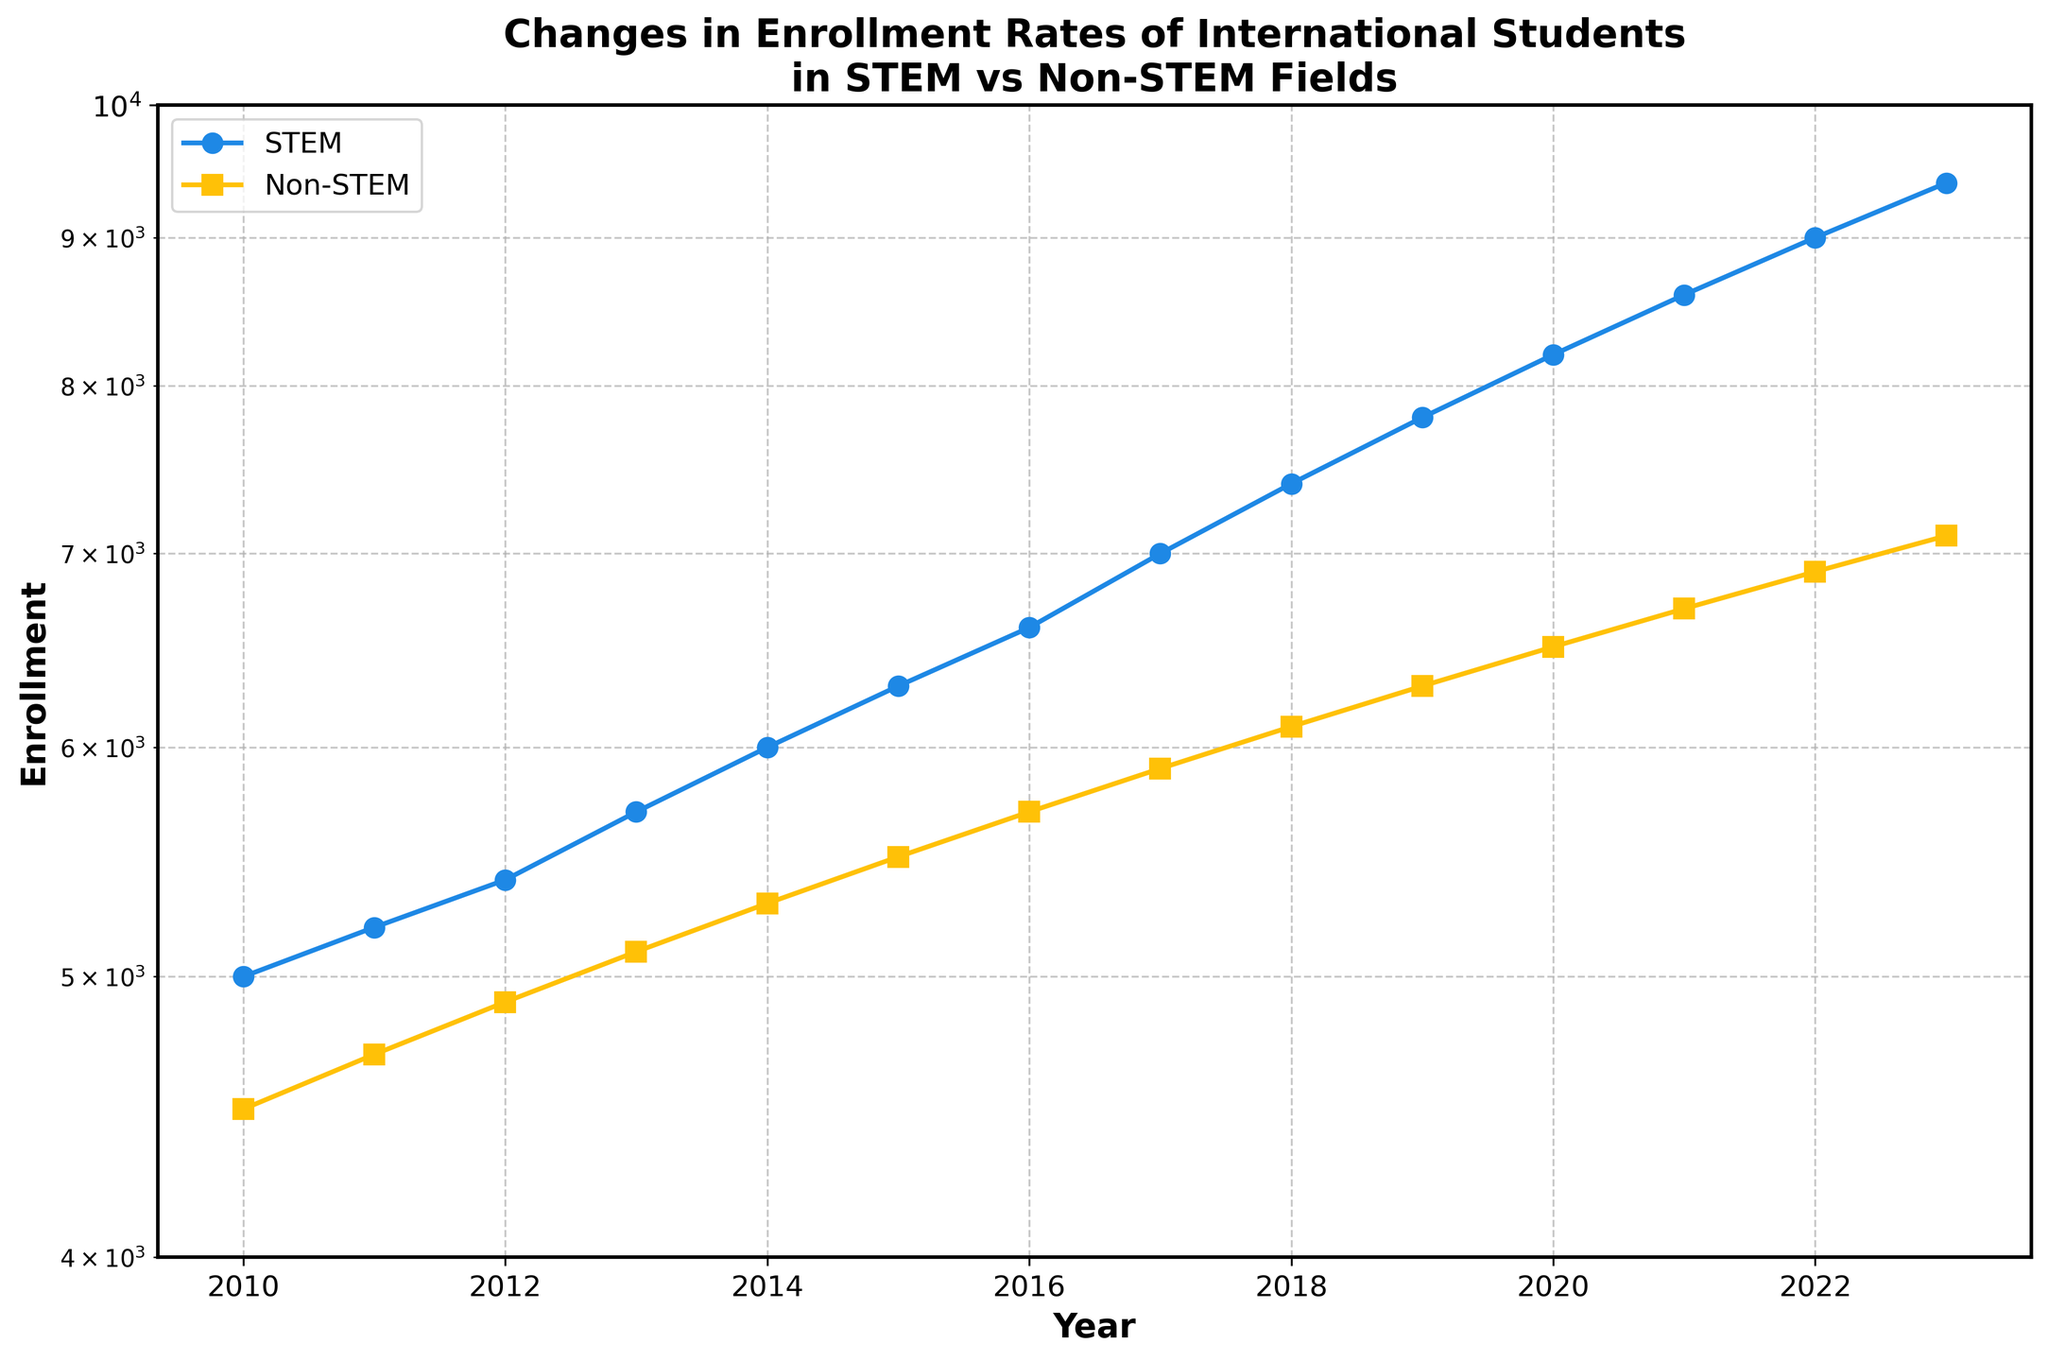What is the title of the plot? The title of the plot is displayed at the top and reads, "Changes in Enrollment Rates of International Students in STEM vs Non-STEM Fields".
Answer: Changes in Enrollment Rates of International Students in STEM vs Non-STEM Fields How many years of data are presented in the plot? The x-axis of the plot shows years ranging from 2010 to 2023, inclusive. To find the number of data points, count each year in this range.
Answer: 14 Which field, STEM or Non-STEM, had higher enrollment in 2013? Look at the values for 2013 on the plot. Compare the enrollment rates for STEM and Non-STEM fields. STEM enrollment is higher.
Answer: STEM What enrollment trend do both STEM and Non-STEM fields show from 2010 to 2023? Observe the direction of both lines on the plot from 2010 to 2023. Both lines show an increasing trend, indicating that enrollment in both fields has increased over these years.
Answer: Increasing In which year does the enrollment for STEM first surpass 7000? Trace the STEM line to find the year where the enrollment first exceeds the 7000 mark by following the y-axis labels. This occurs around 2017.
Answer: 2017 What is the enrollment difference between STEM and Non-STEM fields in 2023? Find the enrollment values for both fields in 2023 from the plot. Subtract the Non-STEM enrollment (7100) from STEM enrollment (9400).
Answer: 2300 How does the enrollment growth rate compare between STEM and Non-STEM fields? Compare the slopes of the two lines. The STEM enrollment line rises more steeply compared to the Non-STEM enrollment line, indicating a higher growth rate for STEM.
Answer: STEM has a higher growth rate Between which years does the Non-STEM enrollment show the smallest increase? Observe the Non-STEM line and identify the segment with the smallest vertical rise. This occurs between 2010 and 2011.
Answer: 2010-2011 At what year do the enrollment lines for STEM and Non-STEM fields look the closest? Identify the points where the two lines appear closest to each other. This occurs around 2012 and 2013.
Answer: 2012-2013 